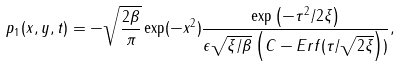Convert formula to latex. <formula><loc_0><loc_0><loc_500><loc_500>p _ { 1 } ( x , y , t ) = - \sqrt { \frac { 2 \beta } { \pi } } \exp ( - x ^ { 2 } ) \frac { \exp \left ( - \tau ^ { 2 } / 2 \xi \right ) } { \epsilon \sqrt { \xi / \beta } \left ( C - E r f ( \tau / \sqrt { 2 \xi } \right ) ) } ,</formula> 